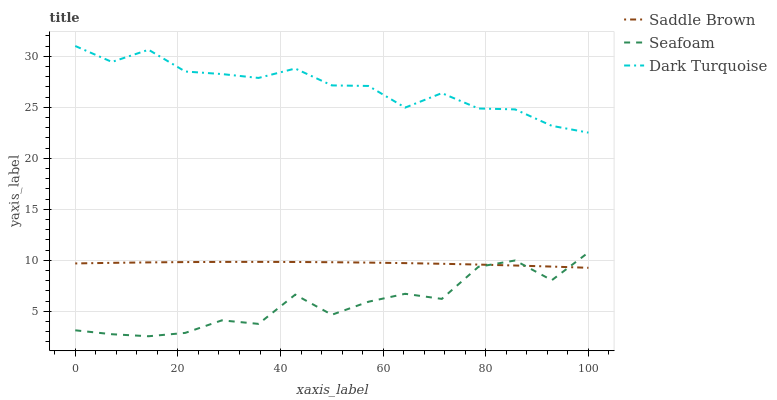Does Saddle Brown have the minimum area under the curve?
Answer yes or no. No. Does Saddle Brown have the maximum area under the curve?
Answer yes or no. No. Is Seafoam the smoothest?
Answer yes or no. No. Is Saddle Brown the roughest?
Answer yes or no. No. Does Saddle Brown have the lowest value?
Answer yes or no. No. Does Seafoam have the highest value?
Answer yes or no. No. Is Seafoam less than Dark Turquoise?
Answer yes or no. Yes. Is Dark Turquoise greater than Saddle Brown?
Answer yes or no. Yes. Does Seafoam intersect Dark Turquoise?
Answer yes or no. No. 